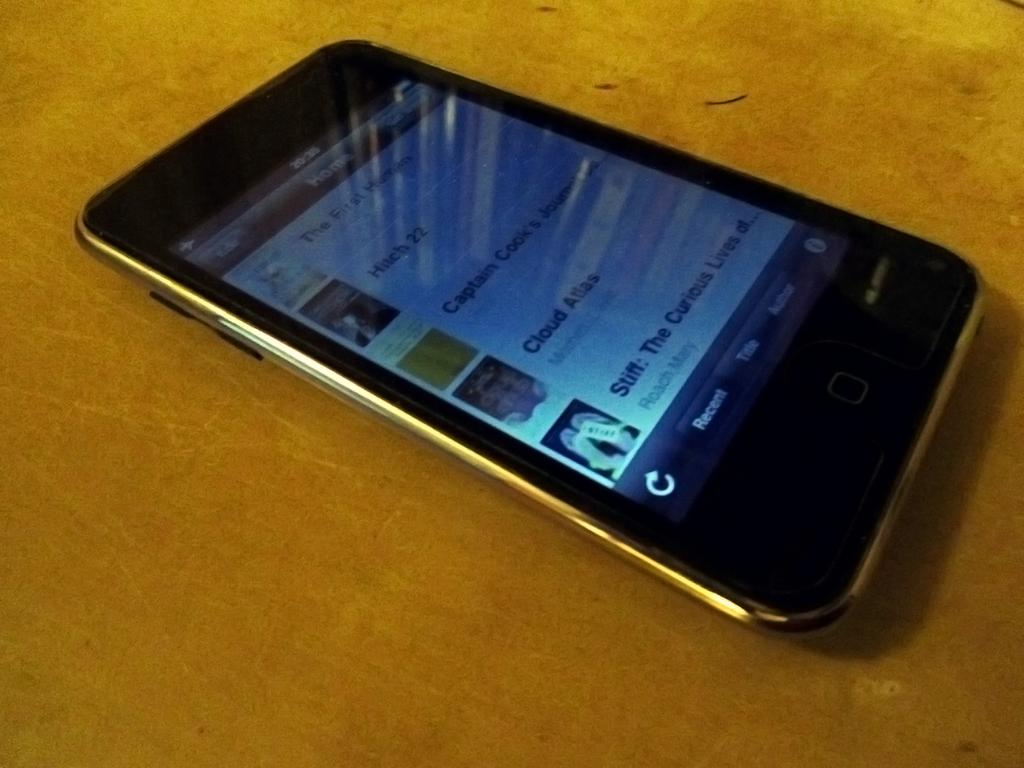<image>
Offer a succinct explanation of the picture presented. A smartphone laying on a table with various bits of media on the Home screen. 